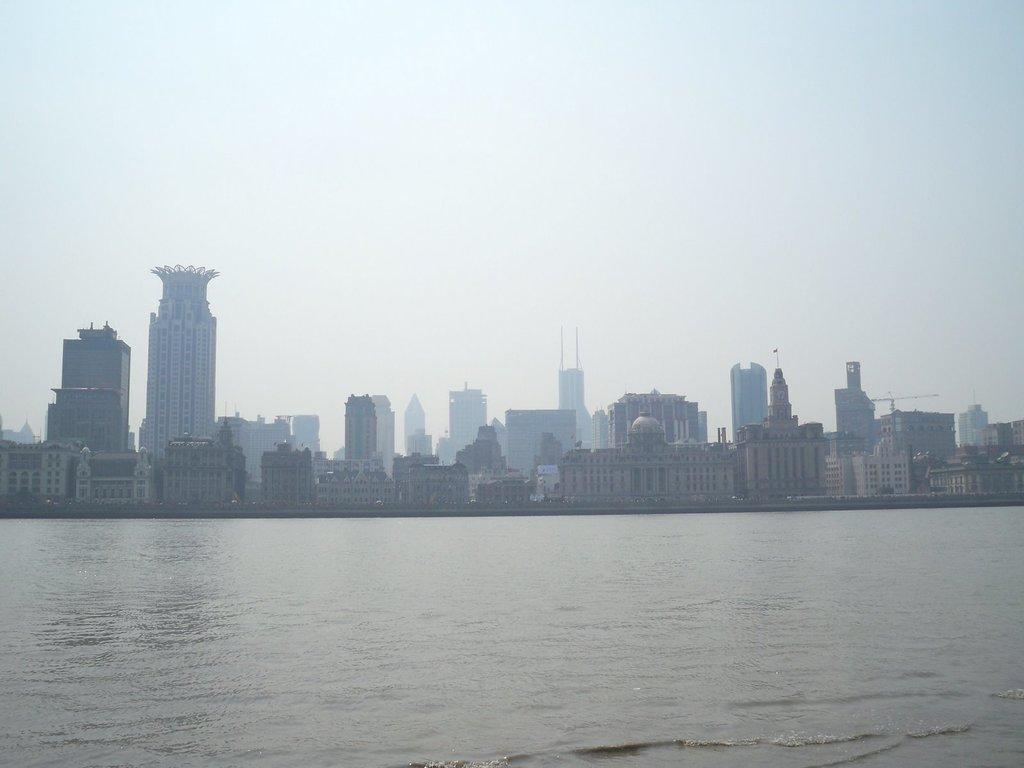Could you give a brief overview of what you see in this image? In this image I can see the water. In the background I can see few buildings and the sky is in white and blue color. 